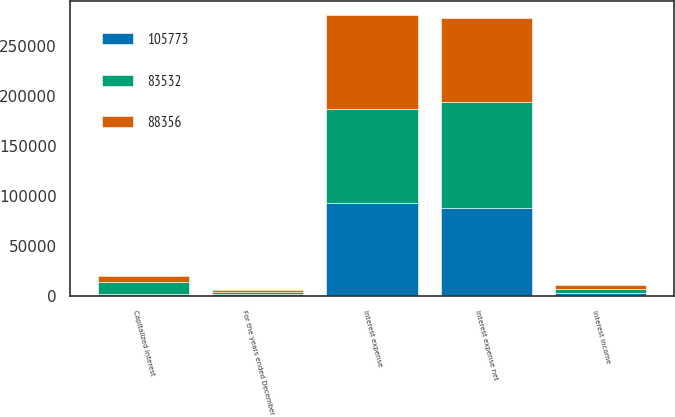Convert chart to OTSL. <chart><loc_0><loc_0><loc_500><loc_500><stacked_bar_chart><ecel><fcel>For the years ended December<fcel>Interest expense<fcel>Capitalized interest<fcel>Interest income<fcel>Interest expense net<nl><fcel>83532<fcel>2015<fcel>93520<fcel>12537<fcel>3536<fcel>105773<nl><fcel>88356<fcel>2014<fcel>93777<fcel>6179<fcel>4066<fcel>83532<nl><fcel>105773<fcel>2013<fcel>93258<fcel>1744<fcel>3158<fcel>88356<nl></chart> 